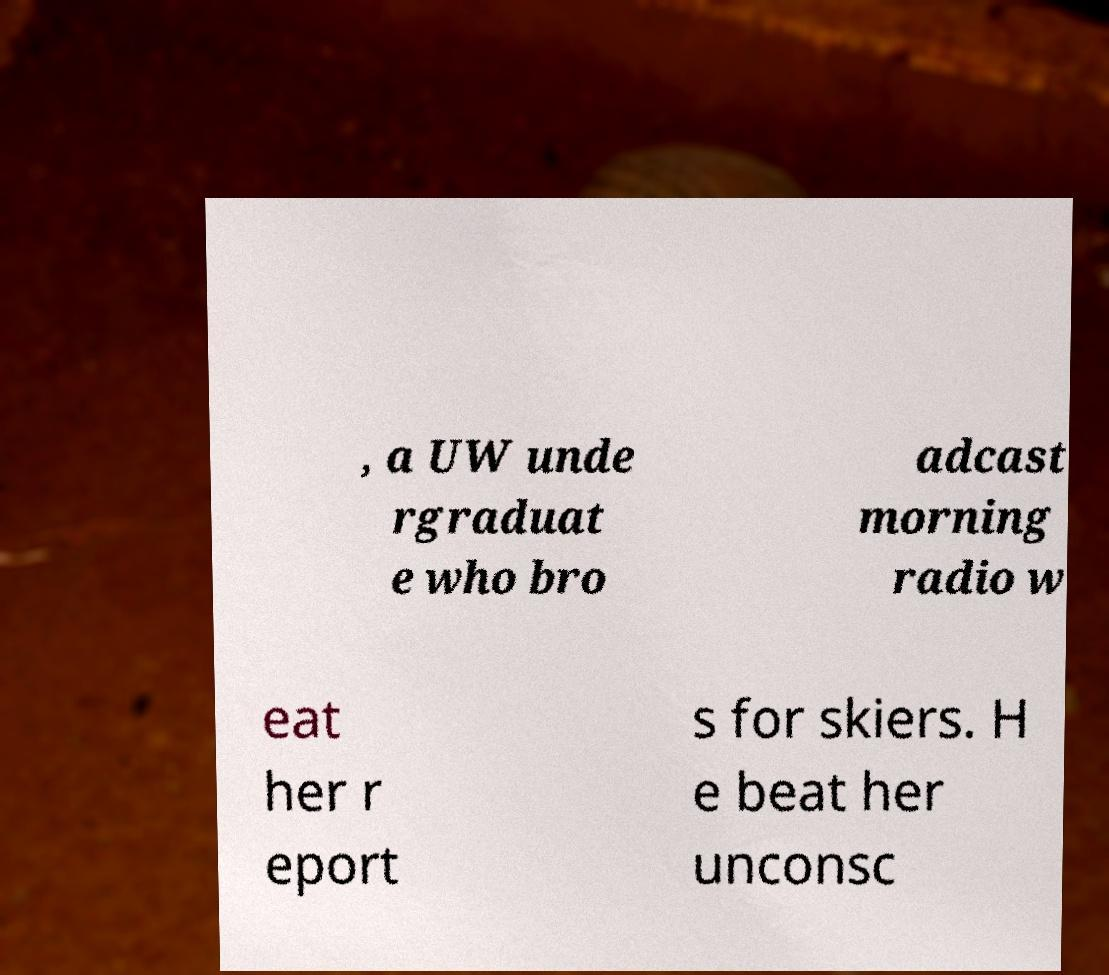Can you accurately transcribe the text from the provided image for me? , a UW unde rgraduat e who bro adcast morning radio w eat her r eport s for skiers. H e beat her unconsc 